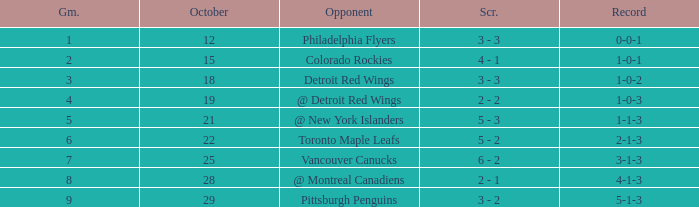Name the least game for record of 5-1-3 9.0. 